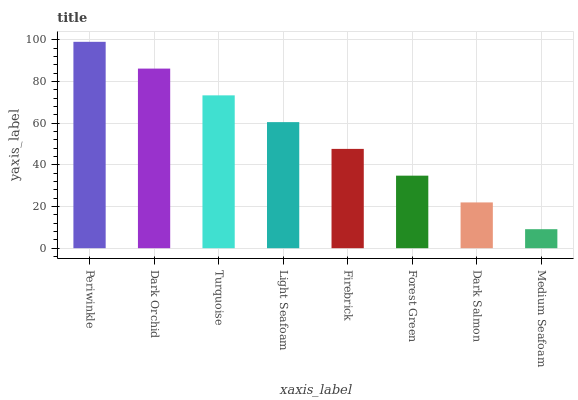Is Medium Seafoam the minimum?
Answer yes or no. Yes. Is Periwinkle the maximum?
Answer yes or no. Yes. Is Dark Orchid the minimum?
Answer yes or no. No. Is Dark Orchid the maximum?
Answer yes or no. No. Is Periwinkle greater than Dark Orchid?
Answer yes or no. Yes. Is Dark Orchid less than Periwinkle?
Answer yes or no. Yes. Is Dark Orchid greater than Periwinkle?
Answer yes or no. No. Is Periwinkle less than Dark Orchid?
Answer yes or no. No. Is Light Seafoam the high median?
Answer yes or no. Yes. Is Firebrick the low median?
Answer yes or no. Yes. Is Medium Seafoam the high median?
Answer yes or no. No. Is Medium Seafoam the low median?
Answer yes or no. No. 